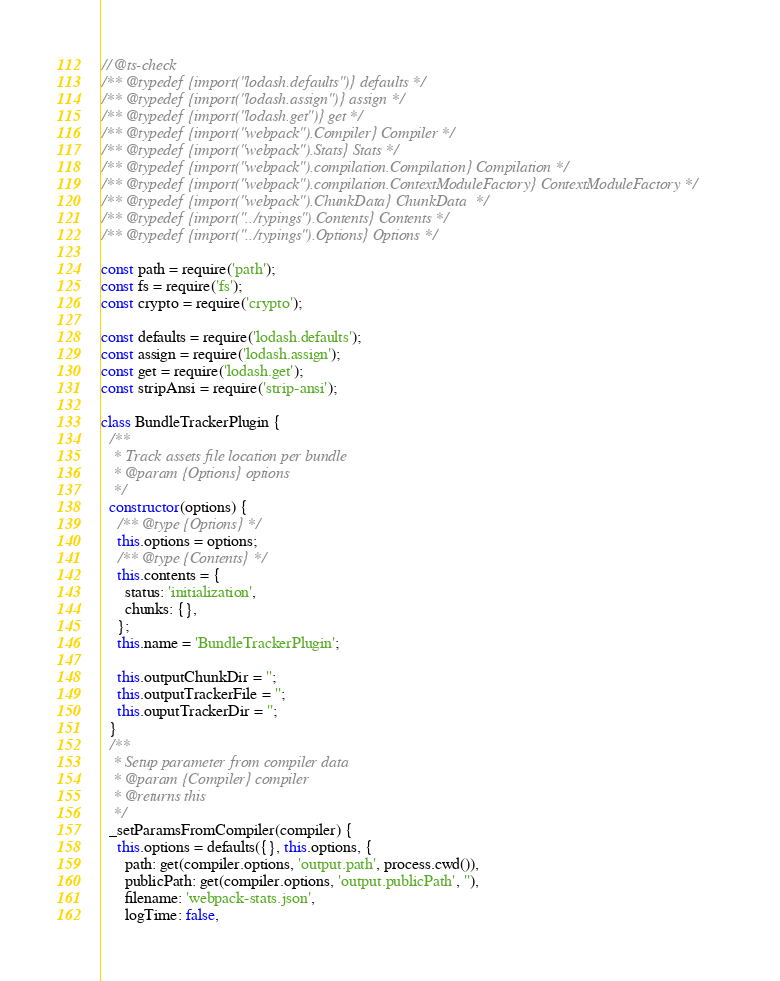Convert code to text. <code><loc_0><loc_0><loc_500><loc_500><_JavaScript_>// @ts-check
/** @typedef {import("lodash.defaults")} defaults */
/** @typedef {import("lodash.assign")} assign */
/** @typedef {import("lodash.get")} get */
/** @typedef {import("webpack").Compiler} Compiler */
/** @typedef {import("webpack").Stats} Stats */
/** @typedef {import("webpack").compilation.Compilation} Compilation */
/** @typedef {import("webpack").compilation.ContextModuleFactory} ContextModuleFactory */
/** @typedef {import("webpack").ChunkData} ChunkData  */
/** @typedef {import("../typings").Contents} Contents */
/** @typedef {import("../typings").Options} Options */

const path = require('path');
const fs = require('fs');
const crypto = require('crypto');

const defaults = require('lodash.defaults');
const assign = require('lodash.assign');
const get = require('lodash.get');
const stripAnsi = require('strip-ansi');

class BundleTrackerPlugin {
  /**
   * Track assets file location per bundle
   * @param {Options} options
   */
  constructor(options) {
    /** @type {Options} */
    this.options = options;
    /** @type {Contents} */
    this.contents = {
      status: 'initialization',
      chunks: {},
    };
    this.name = 'BundleTrackerPlugin';

    this.outputChunkDir = '';
    this.outputTrackerFile = '';
    this.ouputTrackerDir = '';
  }
  /**
   * Setup parameter from compiler data
   * @param {Compiler} compiler
   * @returns this
   */
  _setParamsFromCompiler(compiler) {
    this.options = defaults({}, this.options, {
      path: get(compiler.options, 'output.path', process.cwd()),
      publicPath: get(compiler.options, 'output.publicPath', ''),
      filename: 'webpack-stats.json',
      logTime: false,</code> 